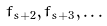Convert formula to latex. <formula><loc_0><loc_0><loc_500><loc_500>f _ { s + 2 } , f _ { s + 3 } , \dots</formula> 